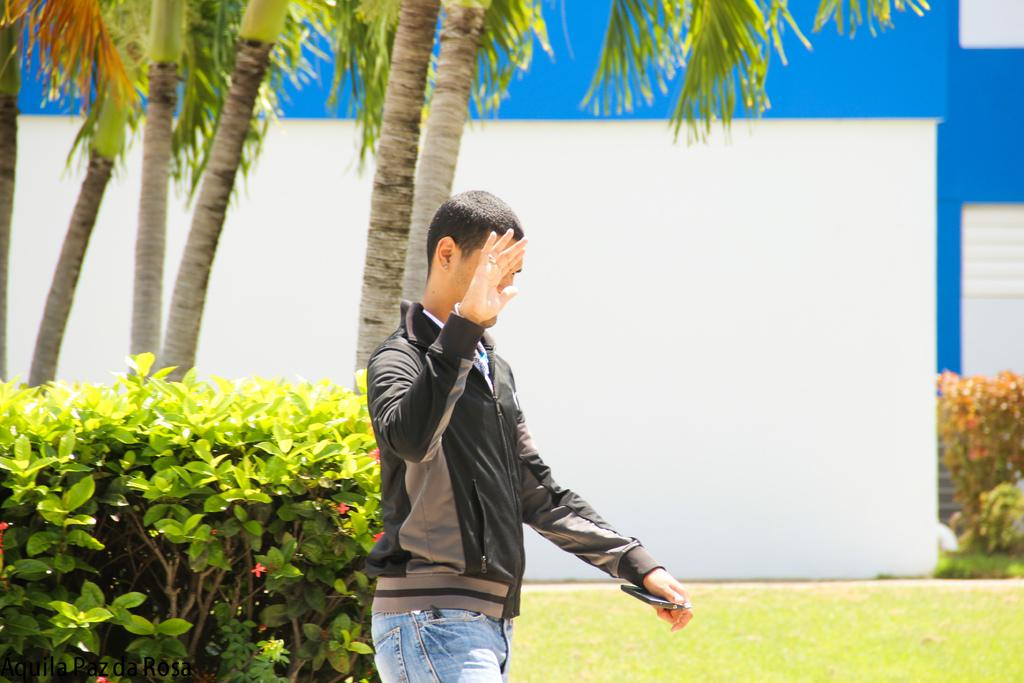What is the main subject in the image? There is a man standing in the image. What can be seen in the background of the image? There are plants and trees visible in the image. What part of a building is present in the image? A part of a house wall is present in the image. Are there any additional plants near the house wall? Yes, there are additional plants beside the house wall. Can you see any cobwebs hanging from the trees in the image? There is no mention of cobwebs in the provided facts, so we cannot determine if any are present in the image. 